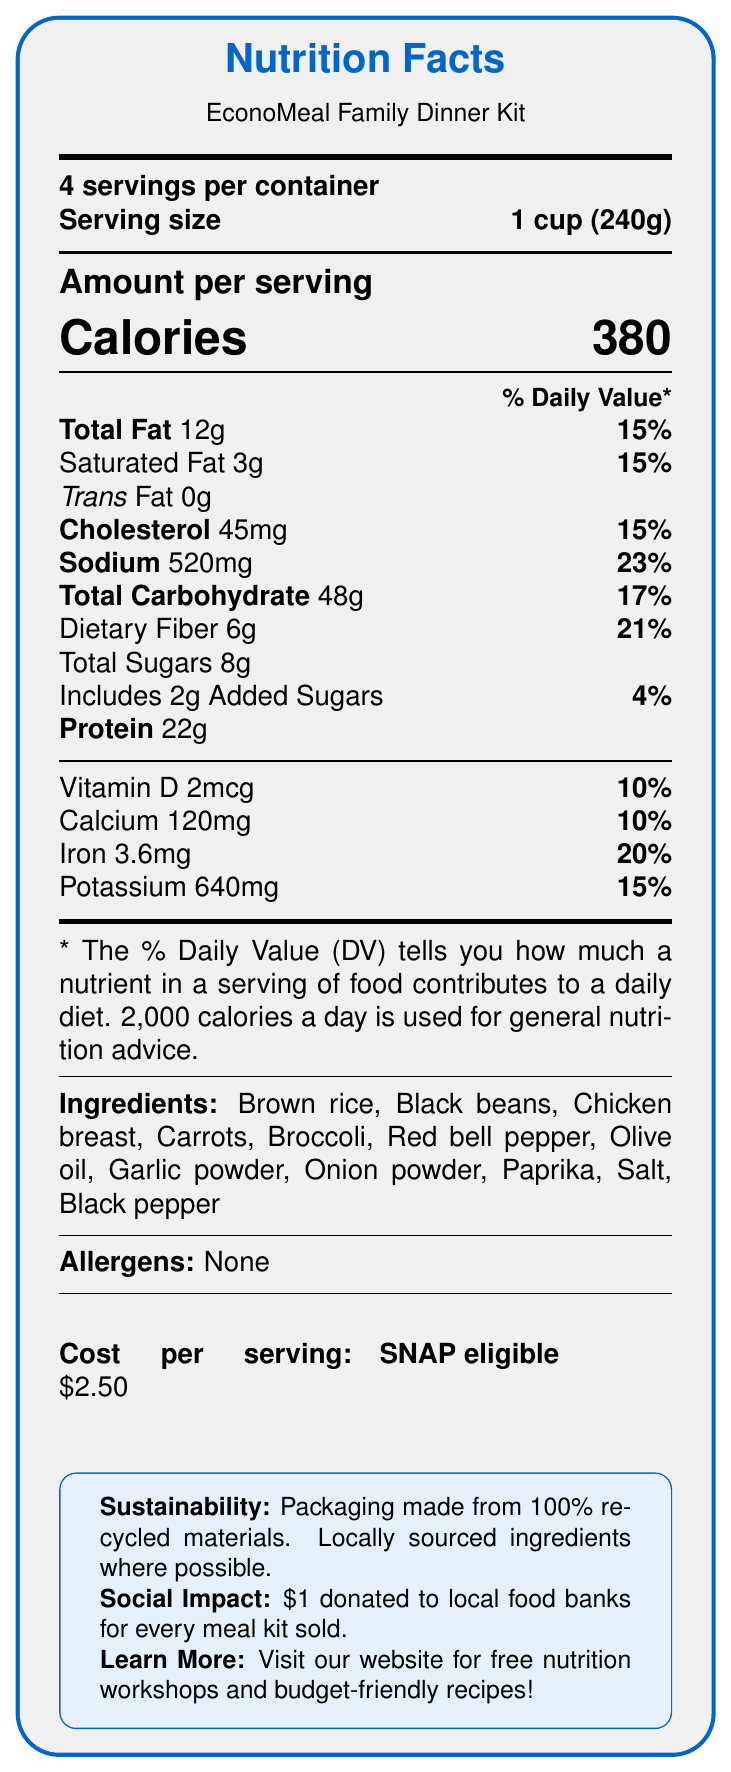what is the serving size for EconoMeal Family Dinner Kit? The serving size is explicitly stated as "1 cup (240g)" in the document.
Answer: 1 cup (240g) how many servings are in the container? The document mentions "4 servings per container."
Answer: 4 how many grams of saturated fat are in one serving? The nutritional facts list the saturated fat content as "3g" per serving.
Answer: 3g what is the potassium content per serving, in percentage of daily value? The nutritional facts indicate that the potassium content per serving is 640mg, which is 15% of the daily value.
Answer: 15% are there any allergens listed in this meal kit? The document states "Allergens: None," indicating that there are no allergens in the meal kit.
Answer: None what are the two primary protein sources in the ingredients list? The ingredients list includes "Chicken breast" and "Black beans," both of which are high in protein.
Answer: Chicken breast and black beans how much dietary fiber does each serving contain? The nutritional facts show that there are 6g of dietary fiber per serving.
Answer: 6g what percentage of the daily value of vitamin D does each serving provide? The document states that each serving provides 2mcg of vitamin D, which is 10% of the daily value.
Answer: 10% how long should you cook the meal kit? The preparation instructions indicate to "Cook over medium heat for 15-20 minutes."
Answer: 15-20 minutes which ingredients are included in the meal kit? The document lists all these components as the ingredients of the meal kit.
Answer: Brown rice, Black beans, Chicken breast, Carrots, Broccoli, Red bell pepper, Olive oil, Garlic powder, Onion powder, Paprika, Salt, Black pepper what is the cost per serving of the meal kit? The document clearly states "Cost per serving: $2.50."
Answer: $2.50 which of the following nutrients is present in the greatest amount per serving? A. Sodium B. Total Carbohydrate C. Protein The nutritional facts indicate that the total carbohydrate content is 48g, which is higher compared to sodium (520mg) and protein (22g).
Answer: B what social benefit does each sale of a meal kit provide? A. Free meals for children B. Donation to local food banks C. Educational programs The document mentions "For every meal kit sold, we donate $1 to local food banks to support families in need."
Answer: B is the packaging of the meal kit environmentally friendly? The document states, "Packaging made from 100% recycled materials," indicating it is environmentally friendly.
Answer: Yes is the meal kit eligible for purchase with SNAP benefits? The document notes "Eligible for purchase with SNAP benefits."
Answer: Yes summarize the main points of the document. The document outlines the nutrition facts, ingredients, allergens, environmental impact, social benefits, cost, and eligibility for SNAP benefits, all promoting a cost-effective, healthy, and socially responsible meal option for families.
Answer: The EconoMeal Family Dinner Kit is a budget-friendly and nutritious meal designed for low-income families. It provides essential nutrients and is cost-effective at $2.50 per serving. The product is environmentally friendly with recycled packaging and has a positive social impact by donating $1 to local food banks for each kit sold. It includes a variety of healthy ingredients and is easy to prepare. how often should this meal kit be consumed as part of a balanced diet? The document does not provide specific recommendations or guidance on how frequently the meal kit should be consumed.
Answer: Cannot be determined 